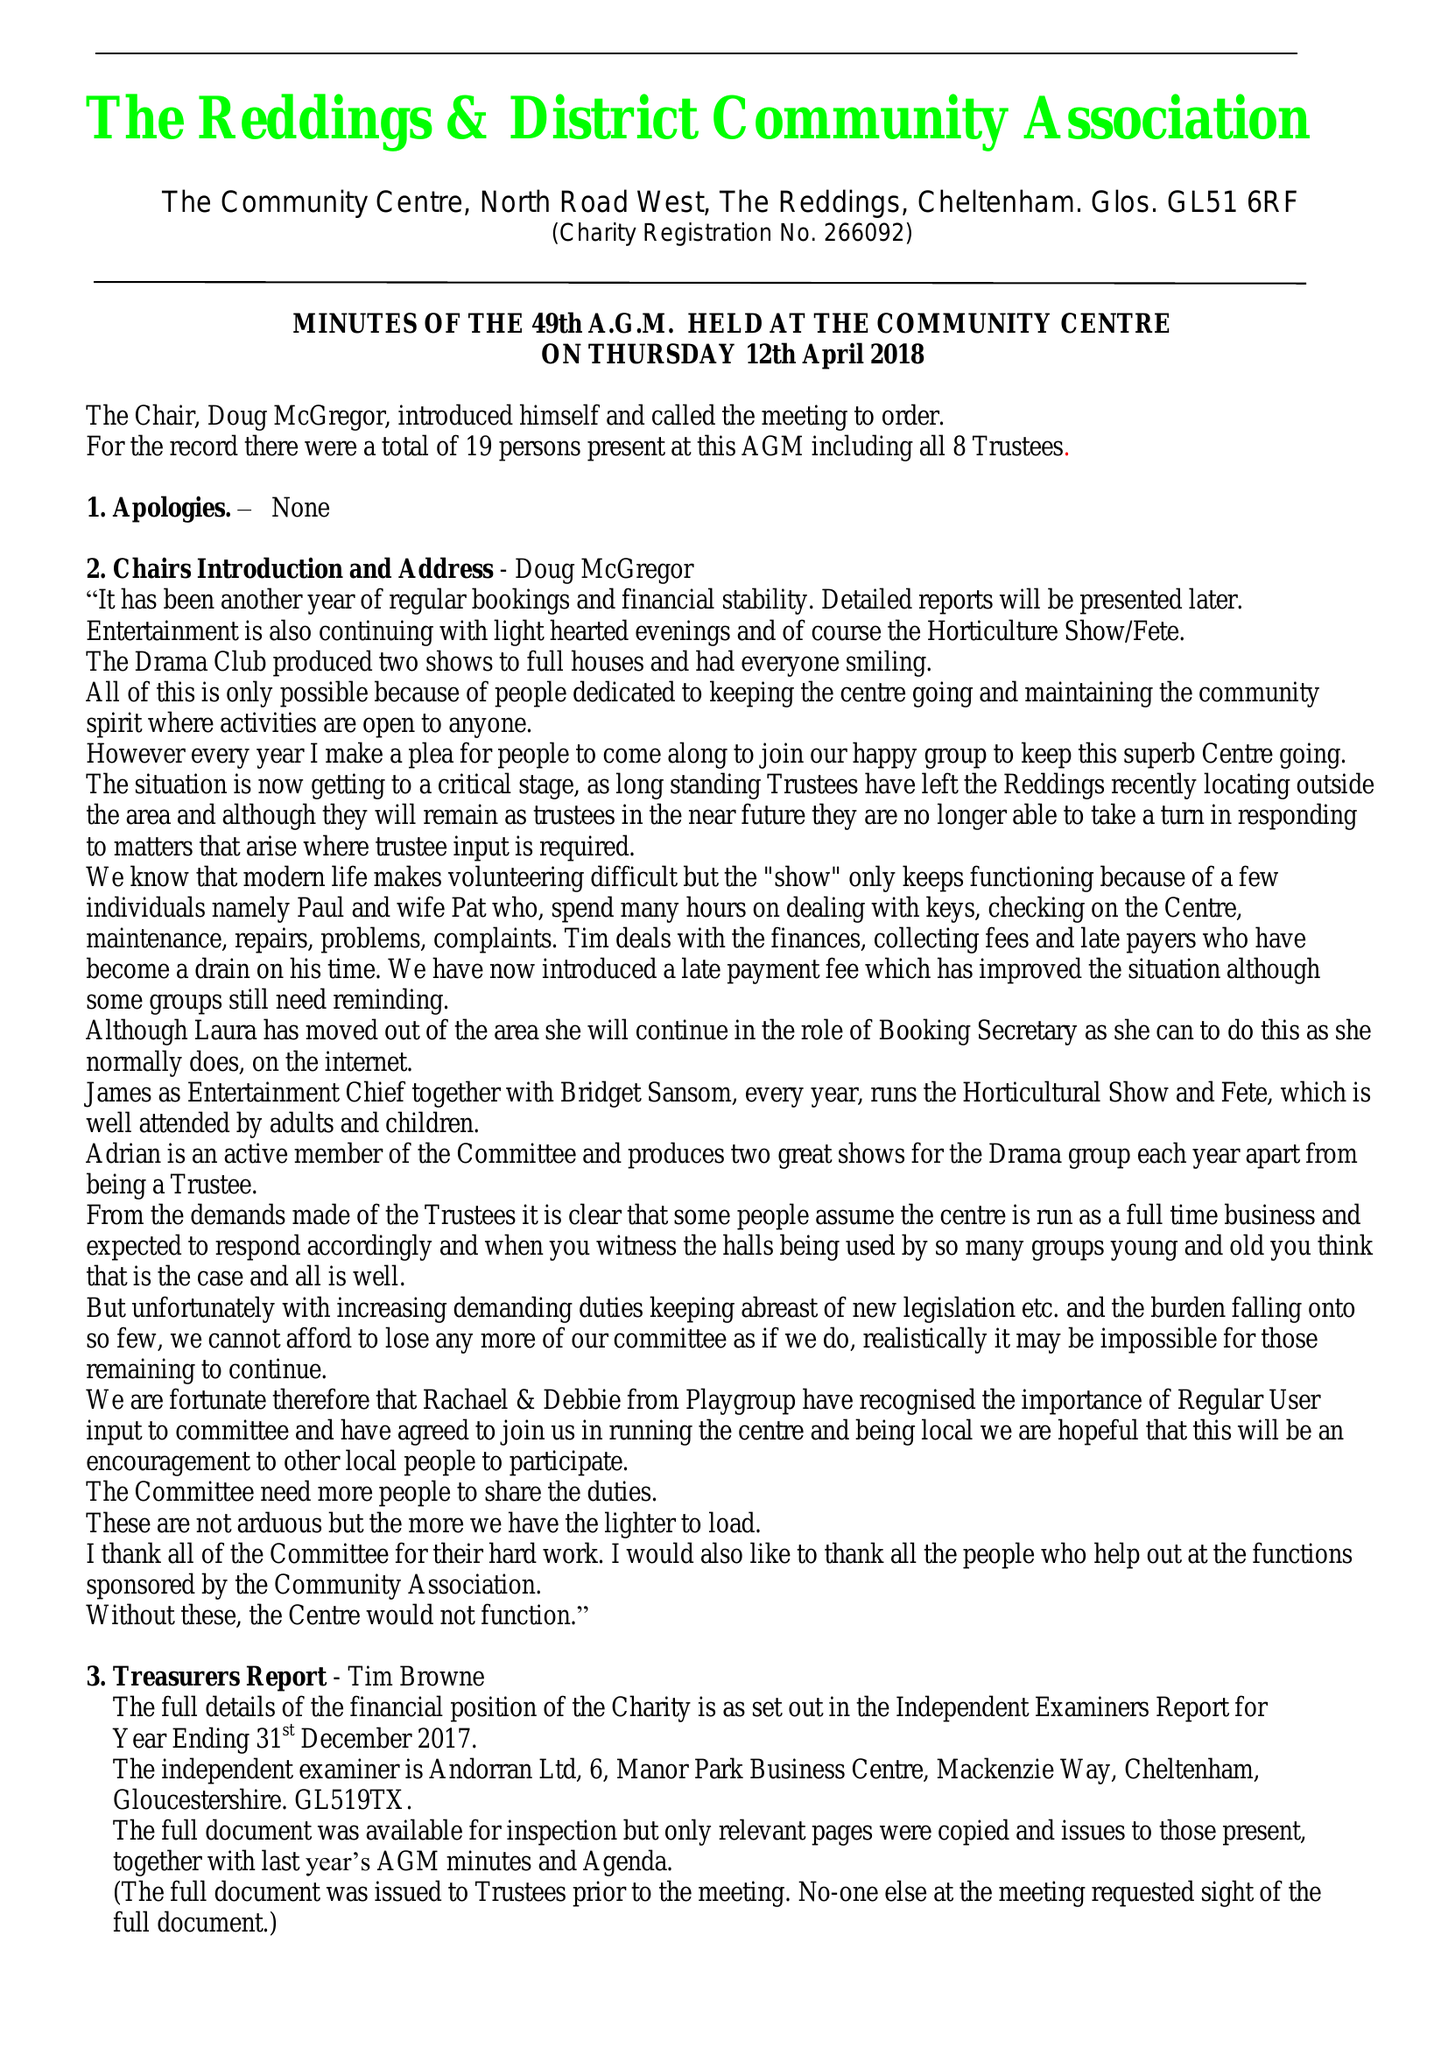What is the value for the address__post_town?
Answer the question using a single word or phrase. CHELTENHAM 